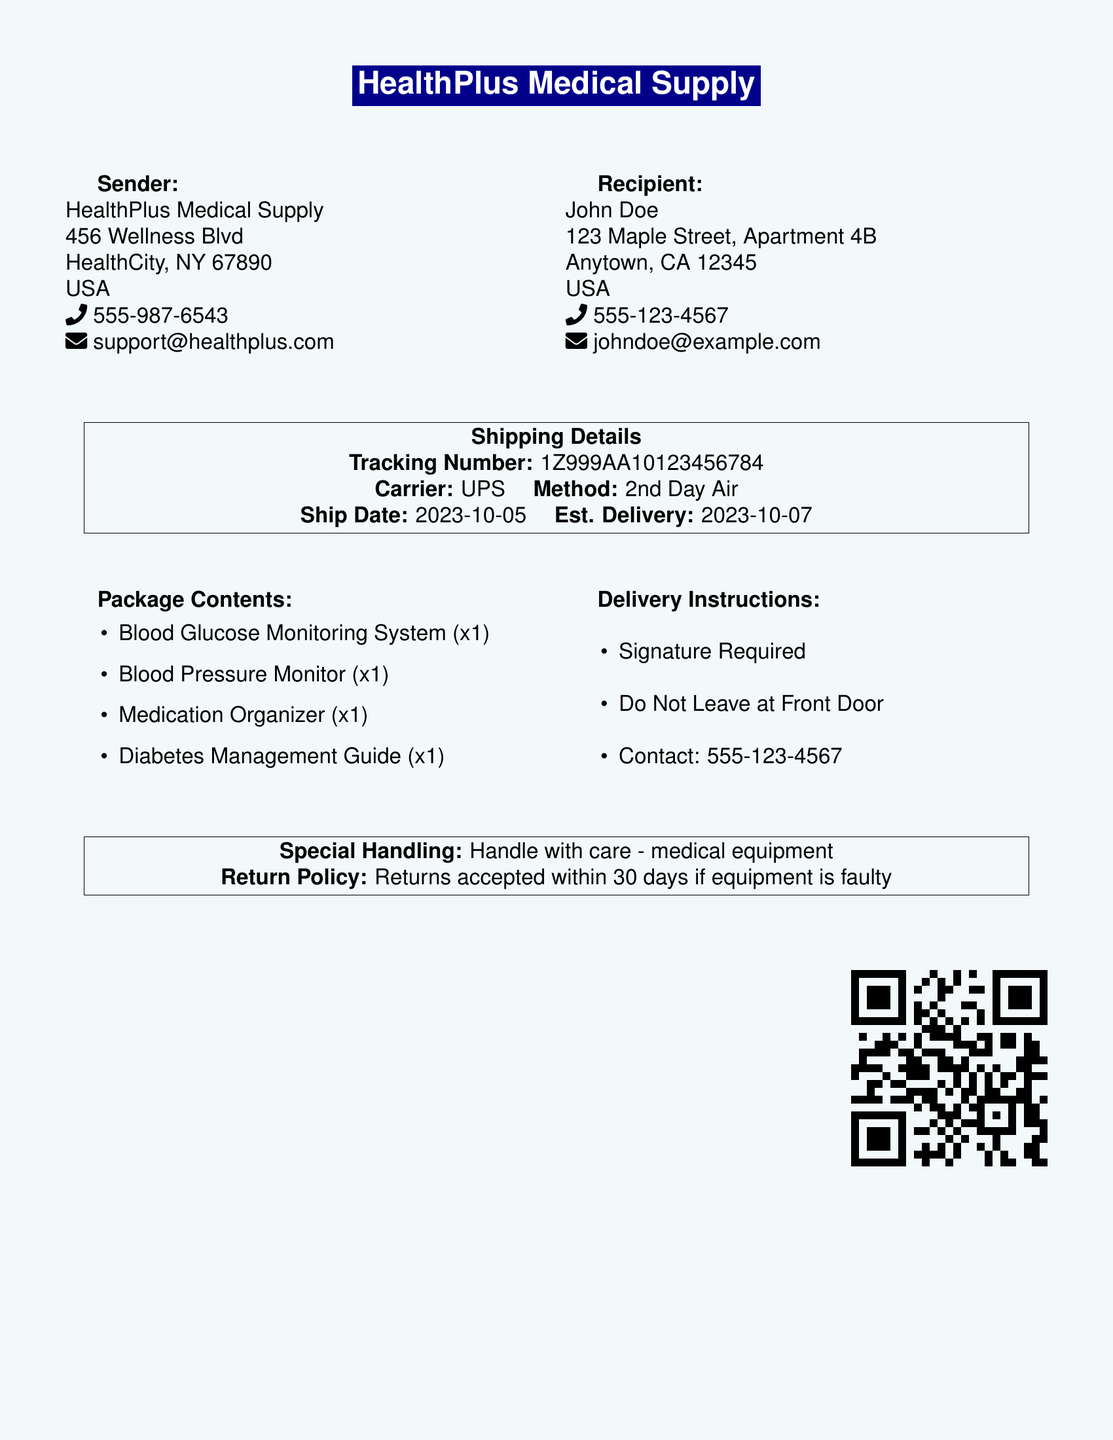what is the name of the sender? The sender's name is mentioned at the top of the document, which is HealthPlus Medical Supply.
Answer: HealthPlus Medical Supply what is the recipient's address? The recipient's address is detailed in the document under the recipient section, consisting of street name, city, state, and ZIP code.
Answer: 123 Maple Street, Apartment 4B, Anytown, CA 12345 what is the tracking number? The tracking number is provided in the shipping details box on the document.
Answer: 1Z999AA10123456784 what is the estimated delivery date? The estimated delivery date is provided in the shipping details section alongside the ship date.
Answer: 2023-10-07 what items are included in the package? The package contents section lists all the items sent with the delivery.
Answer: Blood Glucose Monitoring System, Blood Pressure Monitor, Medication Organizer, Diabetes Management Guide what handling instructions are specified? The special handling section provides instructions about how to handle the package safely.
Answer: Handle with care - medical equipment what is the return policy? The return policy is outlined in the special handling box, indicating conditions for returns.
Answer: Returns accepted within 30 days if equipment is faulty who is the contact person for delivery instructions? The contact information for delivery instructions is provided in the delivery instructions section.
Answer: 555-123-4567 what shipping method is used? The shipping method is specified in the shipping details section under carrier information.
Answer: 2nd Day Air 